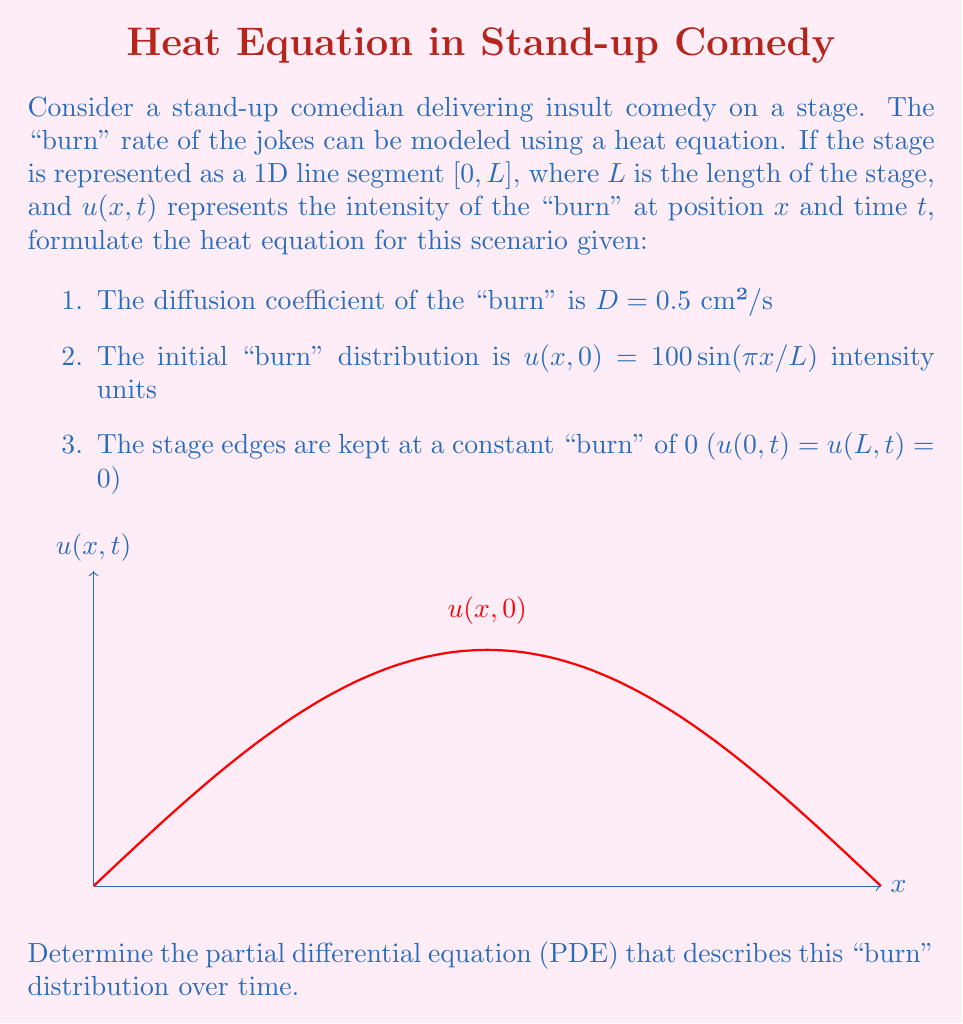Can you solve this math problem? To formulate the heat equation for this scenario, we need to consider the given information and apply it to the general form of the heat equation. Let's proceed step-by-step:

1. The general form of the heat equation in one dimension is:

   $$\frac{\partial u}{\partial t} = D \frac{\partial^2 u}{\partial x^2}$$

   where u is the quantity being diffused (in this case, the "burn" intensity), t is time, x is position, and D is the diffusion coefficient.

2. We are given that D = 0.5 cm²/s. Substituting this into the general equation:

   $$\frac{\partial u}{\partial t} = 0.5 \frac{\partial^2 u}{\partial x^2}$$

3. The initial condition is given as:
   
   u(x,0) = 100 sin(πx/L)

4. The boundary conditions are:
   
   u(0,t) = u(L,t) = 0

5. These conditions don't directly affect the PDE itself, but they are crucial for solving the equation and determining the specific solution for u(x,t).

Therefore, the heat equation describing the "burn" distribution over time on the stage is:

$$\frac{\partial u}{\partial t} = 0.5 \frac{\partial^2 u}{\partial x^2}$$

This equation, combined with the initial and boundary conditions, fully describes the "burn" rate of the insult comedy on the stage over time.
Answer: $$\frac{\partial u}{\partial t} = 0.5 \frac{\partial^2 u}{\partial x^2}$$ 